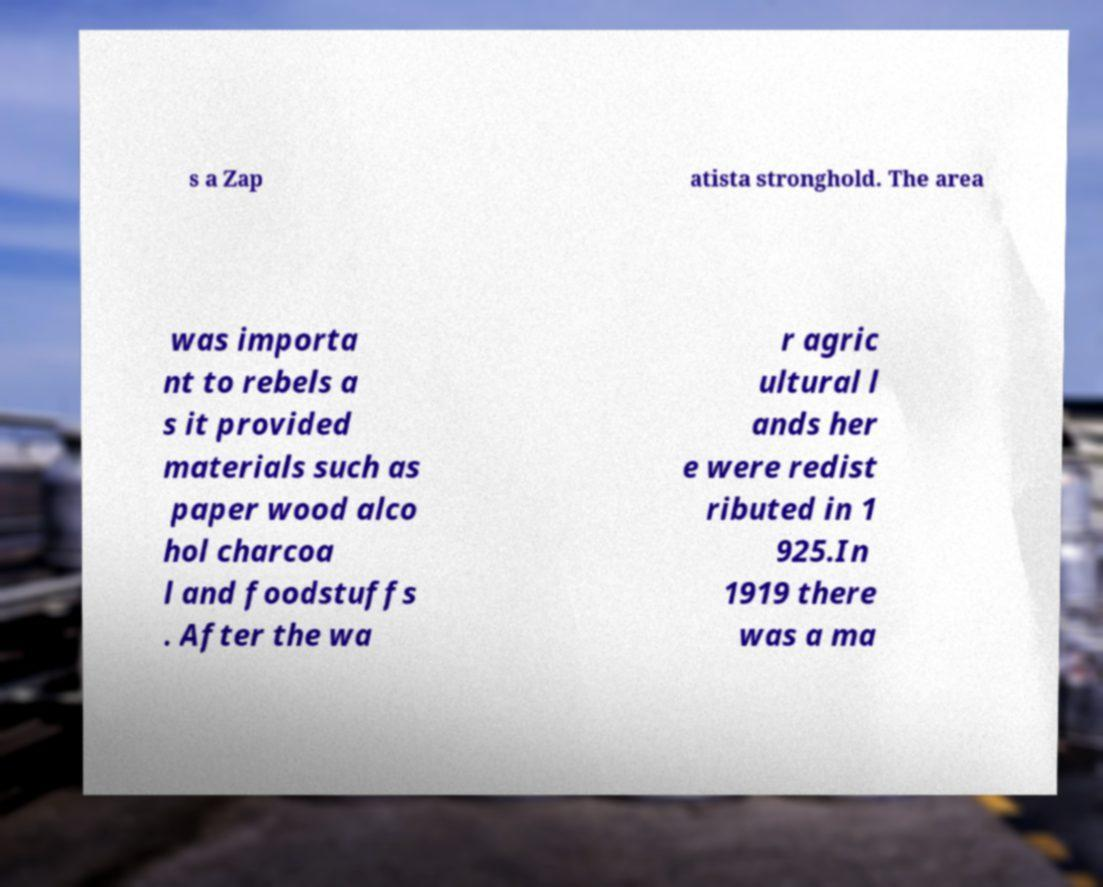Please identify and transcribe the text found in this image. s a Zap atista stronghold. The area was importa nt to rebels a s it provided materials such as paper wood alco hol charcoa l and foodstuffs . After the wa r agric ultural l ands her e were redist ributed in 1 925.In 1919 there was a ma 